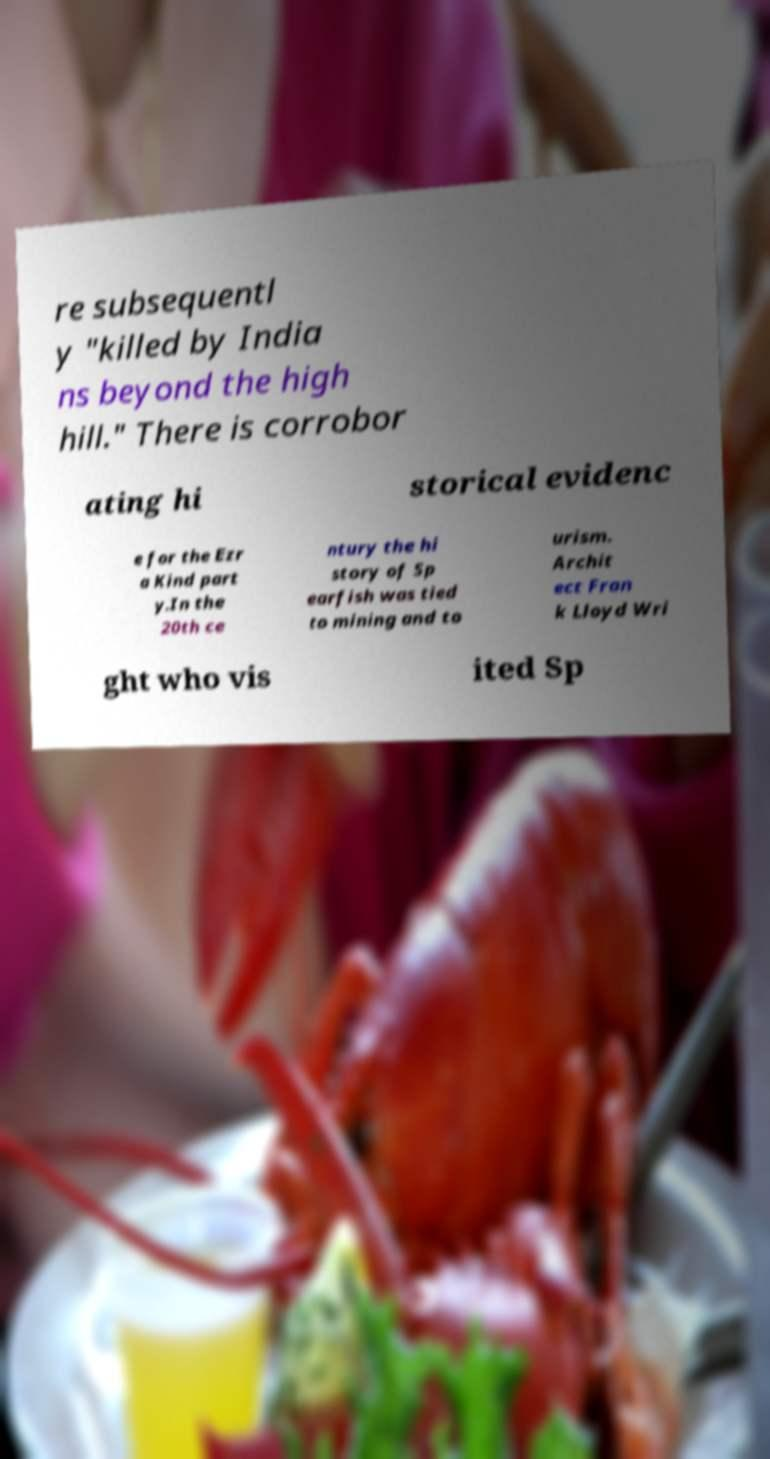Can you accurately transcribe the text from the provided image for me? re subsequentl y "killed by India ns beyond the high hill." There is corrobor ating hi storical evidenc e for the Ezr a Kind part y.In the 20th ce ntury the hi story of Sp earfish was tied to mining and to urism. Archit ect Fran k Lloyd Wri ght who vis ited Sp 